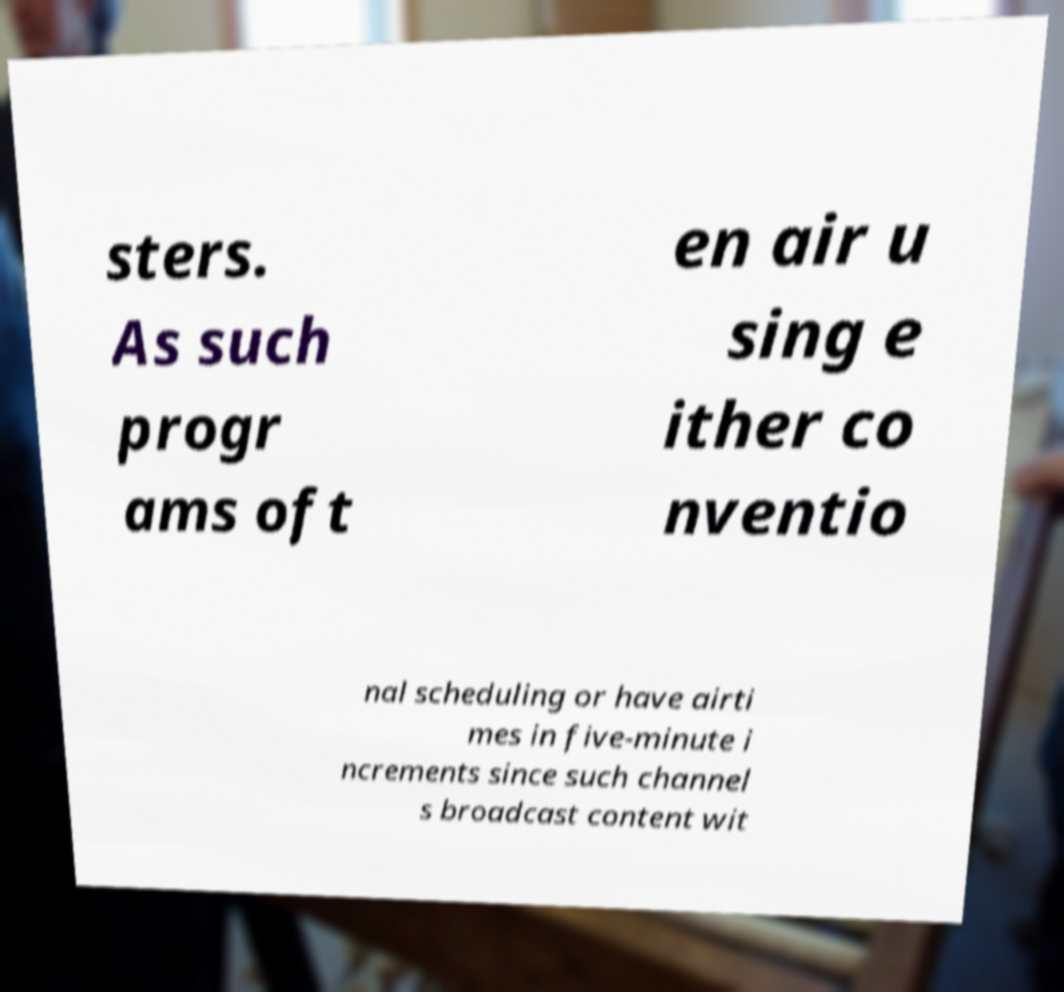Could you extract and type out the text from this image? sters. As such progr ams oft en air u sing e ither co nventio nal scheduling or have airti mes in five-minute i ncrements since such channel s broadcast content wit 